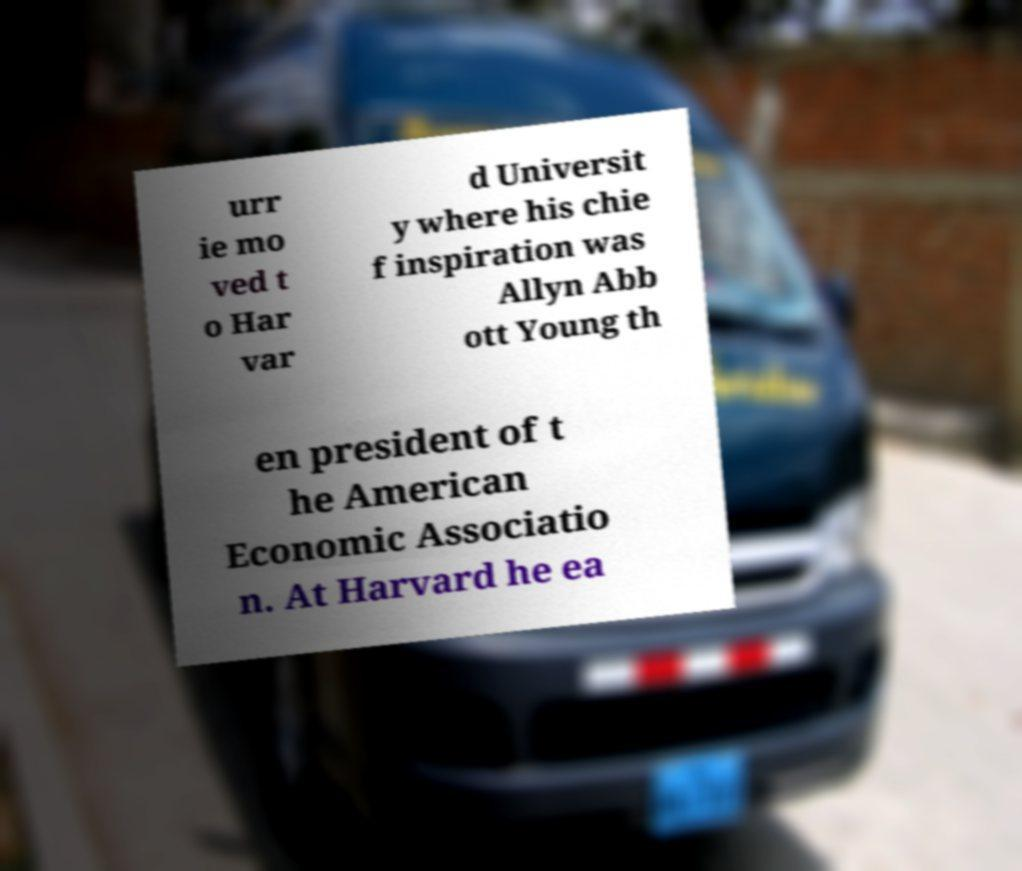Could you extract and type out the text from this image? urr ie mo ved t o Har var d Universit y where his chie f inspiration was Allyn Abb ott Young th en president of t he American Economic Associatio n. At Harvard he ea 